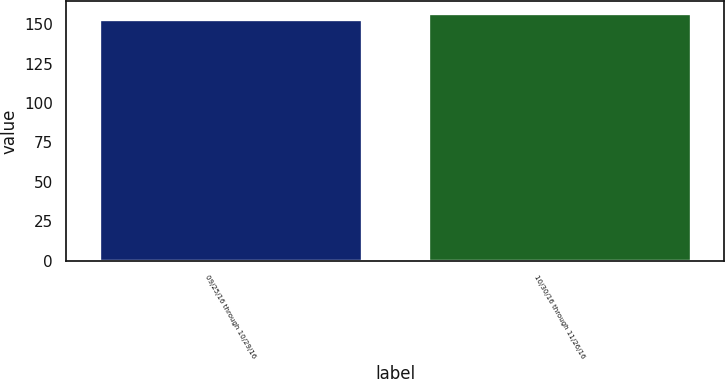Convert chart. <chart><loc_0><loc_0><loc_500><loc_500><bar_chart><fcel>09/25/16 through 10/29/16<fcel>10/30/16 through 11/26/16<nl><fcel>153.44<fcel>156.95<nl></chart> 